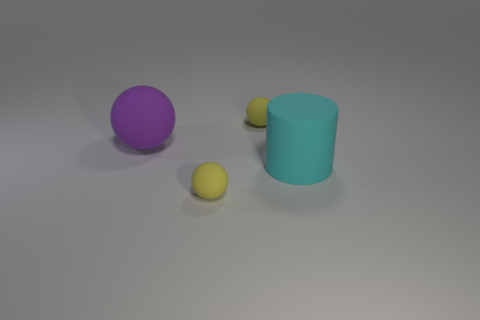Is the number of small rubber objects that are in front of the large cyan thing greater than the number of big purple balls on the right side of the big rubber ball?
Ensure brevity in your answer.  Yes. There is a yellow ball behind the big cyan thing; how many yellow rubber balls are behind it?
Offer a terse response. 0. Do the cyan cylinder and the purple thing have the same size?
Keep it short and to the point. Yes. The tiny yellow thing that is in front of the tiny rubber object behind the big purple rubber thing is made of what material?
Offer a terse response. Rubber. Do the purple ball that is behind the rubber cylinder and the big cyan object have the same size?
Offer a terse response. Yes. How many metal objects are either large brown cubes or cyan objects?
Give a very brief answer. 0. Is the big cyan cylinder made of the same material as the big purple sphere?
Ensure brevity in your answer.  Yes. The cyan thing is what shape?
Offer a terse response. Cylinder. How many objects are either purple rubber things or yellow rubber balls that are in front of the large cyan cylinder?
Your response must be concise. 2. Is the color of the small sphere behind the matte cylinder the same as the big rubber sphere?
Keep it short and to the point. No. 